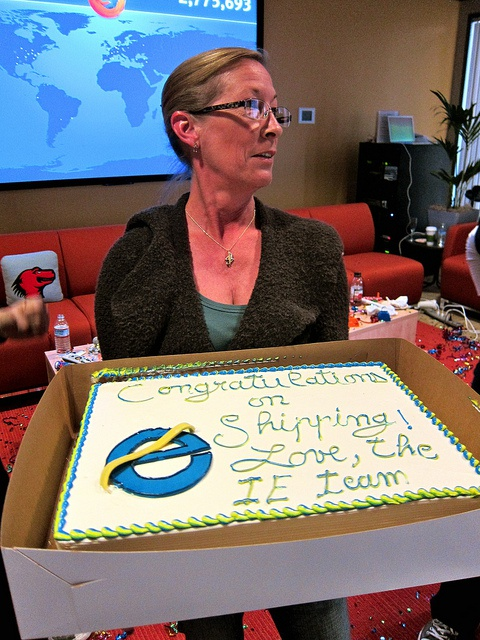Describe the objects in this image and their specific colors. I can see cake in lightblue, beige, gray, and khaki tones, people in lightblue, black, salmon, brown, and maroon tones, tv in lightblue tones, couch in lightblue, brown, maroon, black, and darkgray tones, and potted plant in lightblue, black, gray, and darkgray tones in this image. 